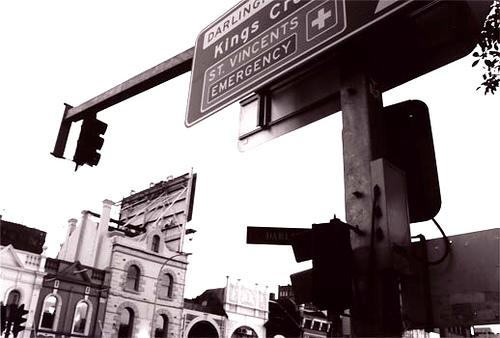What is the name of the street being shown in this picture?
Answer briefly. Kings. What word is under St. Vincents?
Keep it brief. Emergency. Where is the traffic light?
Short answer required. Pole. What kind of institution will I go to if I follow the sign?
Keep it brief. Hospital. 